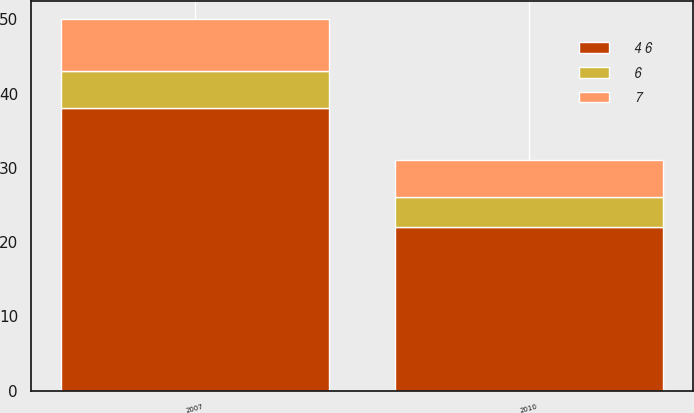Convert chart to OTSL. <chart><loc_0><loc_0><loc_500><loc_500><stacked_bar_chart><ecel><fcel>2007<fcel>2010<nl><fcel>4 6<fcel>38<fcel>22<nl><fcel>7<fcel>7<fcel>5<nl><fcel>6<fcel>5<fcel>4<nl></chart> 